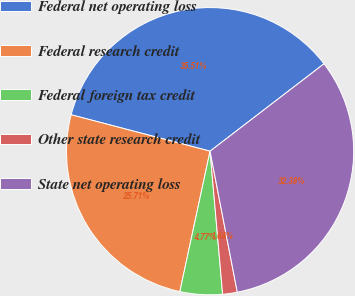<chart> <loc_0><loc_0><loc_500><loc_500><pie_chart><fcel>Federal net operating loss<fcel>Federal research credit<fcel>Federal foreign tax credit<fcel>Other state research credit<fcel>State net operating loss<nl><fcel>35.51%<fcel>25.71%<fcel>4.77%<fcel>1.64%<fcel>32.38%<nl></chart> 